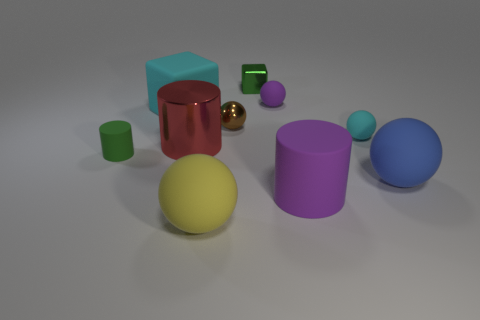Are there the same number of big things on the right side of the big yellow rubber ball and green cubes?
Your answer should be compact. No. Are there any blue rubber objects of the same shape as the big yellow thing?
Provide a succinct answer. Yes. What is the shape of the thing that is both to the right of the big purple matte cylinder and behind the big blue thing?
Keep it short and to the point. Sphere. Does the big blue sphere have the same material as the tiny object in front of the red shiny thing?
Keep it short and to the point. Yes. There is a cyan rubber ball; are there any cyan rubber blocks to the right of it?
Give a very brief answer. No. What number of objects are either large metallic cylinders or small green cylinders in front of the big rubber block?
Your response must be concise. 2. There is a big cylinder left of the big ball in front of the blue ball; what color is it?
Keep it short and to the point. Red. How many other things are made of the same material as the small green cube?
Ensure brevity in your answer.  2. How many metal things are big brown cylinders or purple cylinders?
Your answer should be compact. 0. What is the color of the metal object that is the same shape as the tiny green rubber object?
Your response must be concise. Red. 